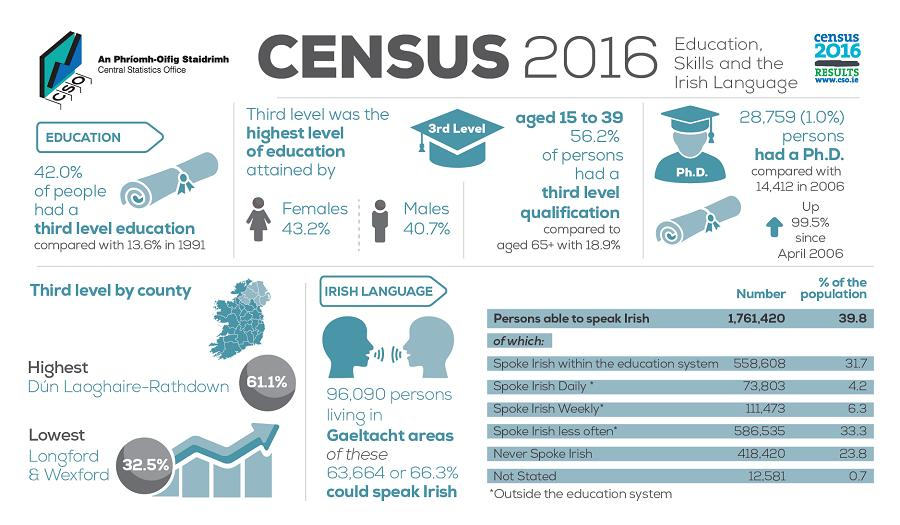List a handful of essential elements in this visual. According to the given data, 43.2% of the population is female. According to the provided data, 40.7% of the males in the population fall within the age range of 20-29. 